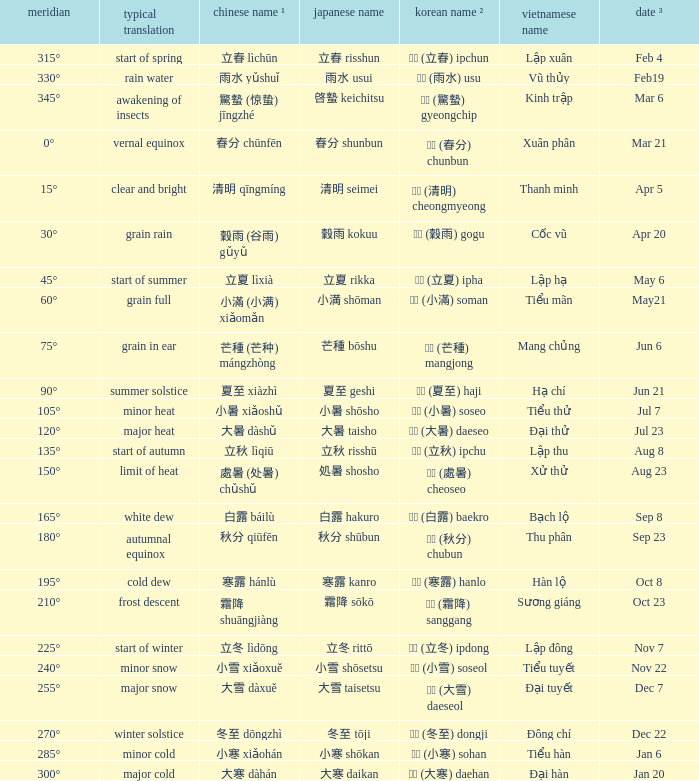WHICH Usual translation is on jun 21? Summer solstice. 